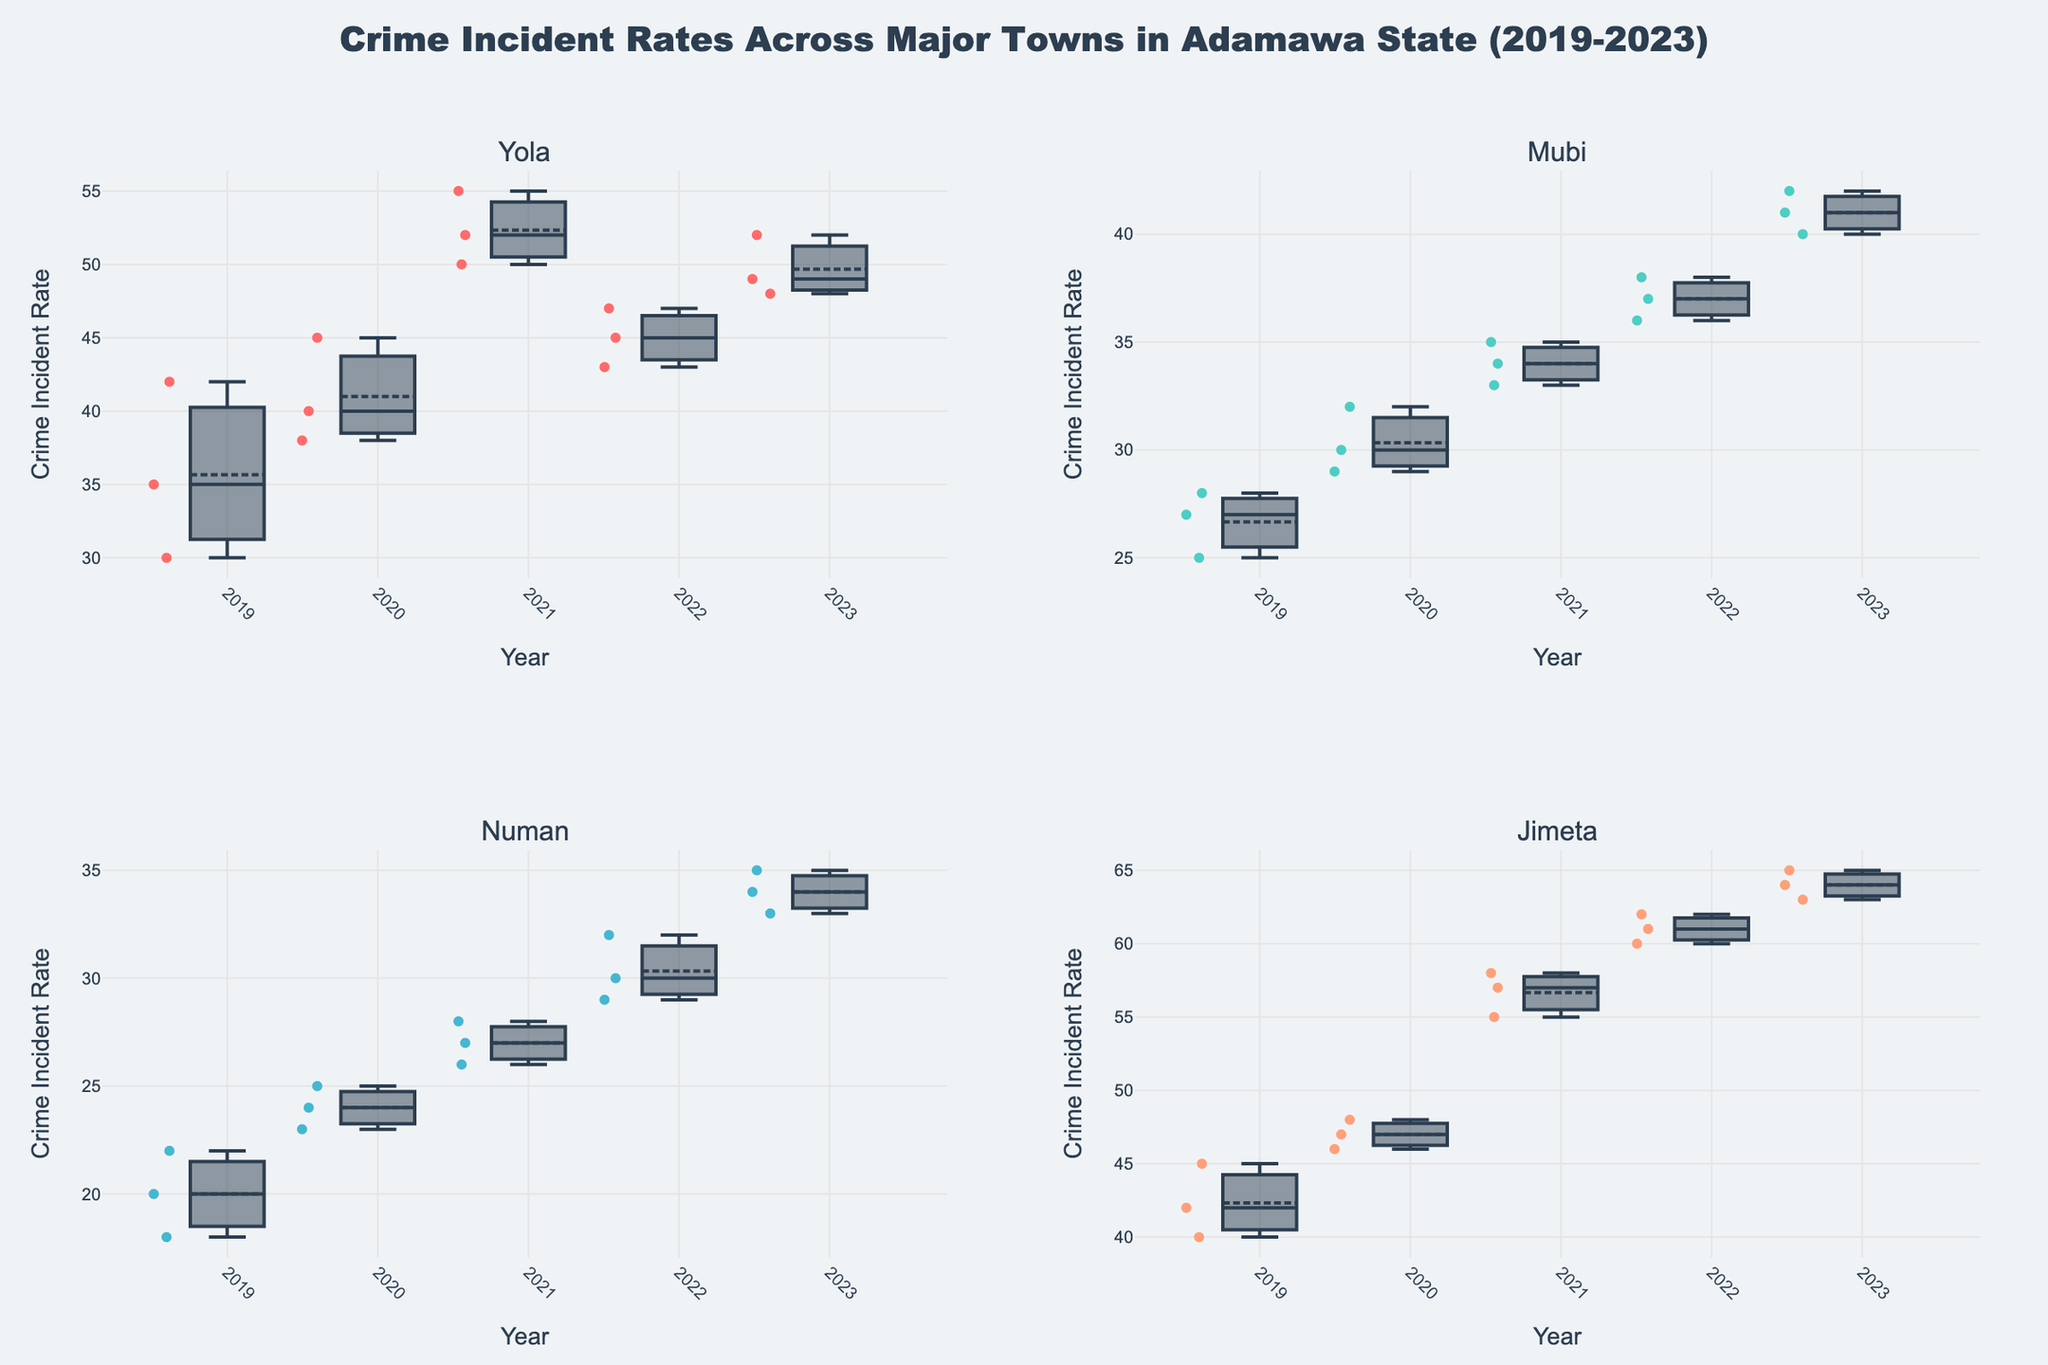What's the median crime incident rate for Yola in 2022? Locate the box plot for Yola in 2022 in the figure. The median rate is represented by the line inside the box.
Answer: 45 Which town had the highest median crime incident rate in 2021? Compare the median lines inside the boxes for each town for the year 2021. Jimeta's median line is the highest.
Answer: Jimeta What is the interquartile range (IQR) of crime incident rates in Mubi for 2020? Identify the box plot for Mubi in 2020. The IQR is the distance between the top and bottom of the box (Q3 - Q1).
Answer: 3 (32 - 29 = 3) How did the median crime incident rate in Numan change from 2019 to 2020? Compare the median line inside the boxes for Numan for the years 2019 and 2020. The median increased from 2019 to 2020.
Answer: Increased Which year shows the highest variability in crime incident rates for Jimeta? Identify the year with the largest IQR in Jimeta's box plots. The year 2021 shows the highest variability with the largest IQR.
Answer: 2021 Which town experienced a decrease in the median crime incident rate between 2021 and 2022? Compare the median lines for each town between 2021 and 2022 to see if there was a decrease. Yola experienced a decrease.
Answer: Yola What was the highest individual crime incident rate observed in Numan over the 5 years? Look for the highest individual point that lies outside of Numan's box plots in any year. The highest point is 35 in 2023.
Answer: 35 Compare the median crime incident rates for 2023 across all towns. Which ones have the same median? Locate the median line for each town's box plot for 2023 and compare. Numan and Yola have the same median in 2023.
Answer: Numan and Yola What trend, if any, is observed in Jimeta's crime incident rates over the five years? Observe the medians in the box plots for Jimeta across the years 2019 to 2023. The medians show an increasing trend.
Answer: Increasing Between Mubi and Yola, which town had less variability in crime incident rates in 2023? Compare the IQRs of the box plots for both towns in 2023. Mubi had a smaller IQR than Yola, indicating less variability.
Answer: Mubi 